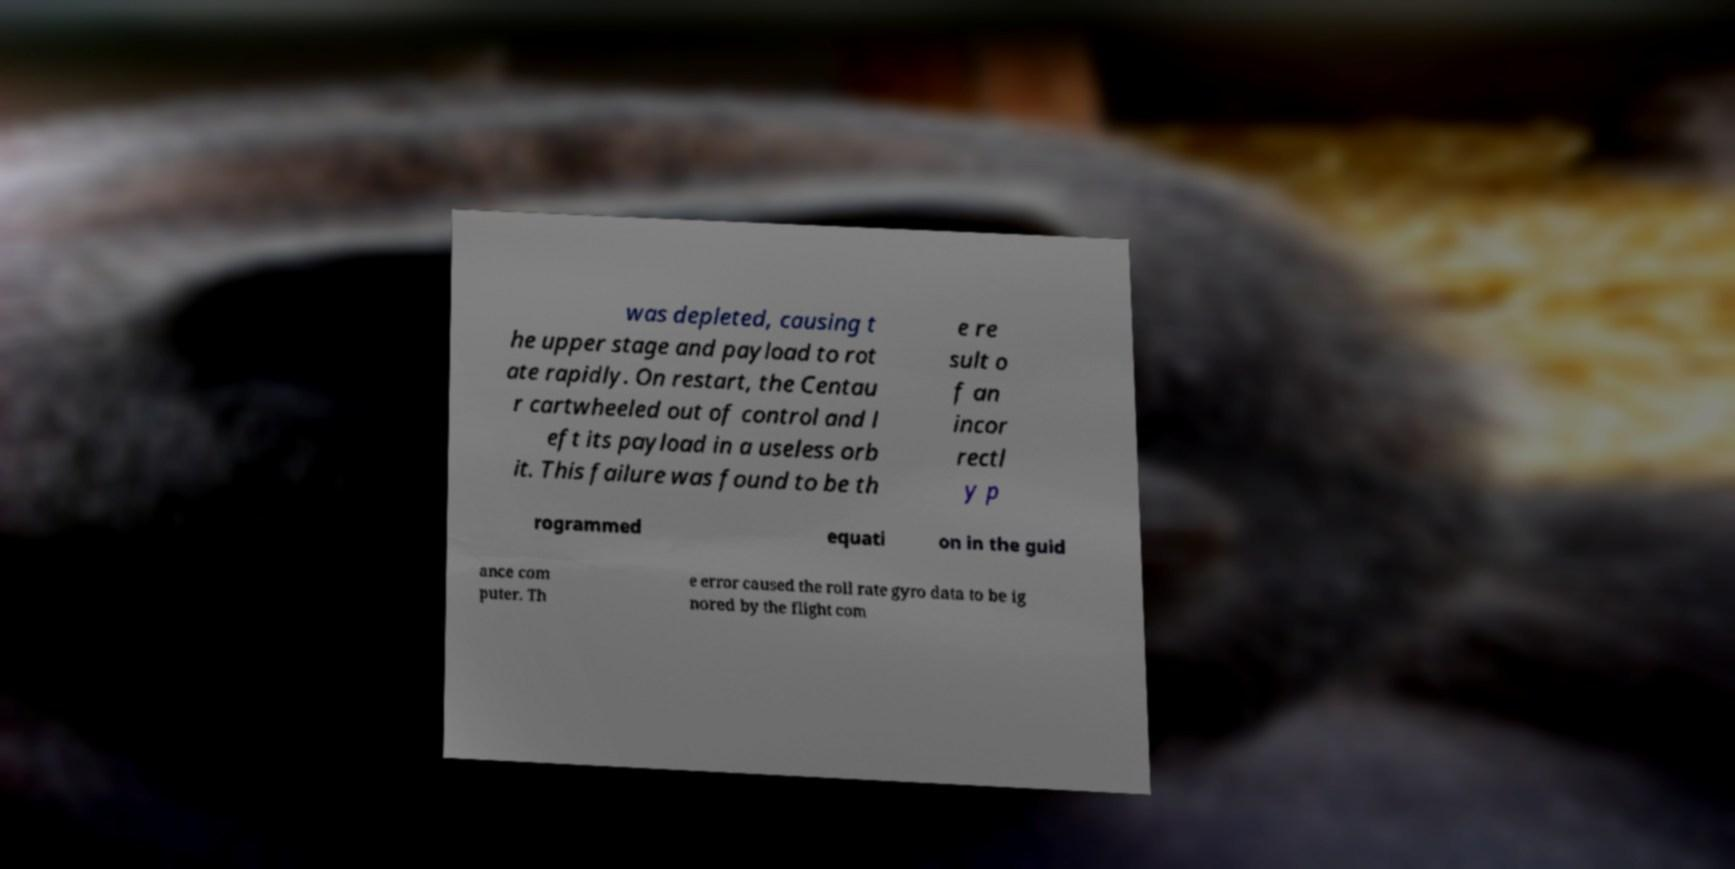Could you extract and type out the text from this image? was depleted, causing t he upper stage and payload to rot ate rapidly. On restart, the Centau r cartwheeled out of control and l eft its payload in a useless orb it. This failure was found to be th e re sult o f an incor rectl y p rogrammed equati on in the guid ance com puter. Th e error caused the roll rate gyro data to be ig nored by the flight com 